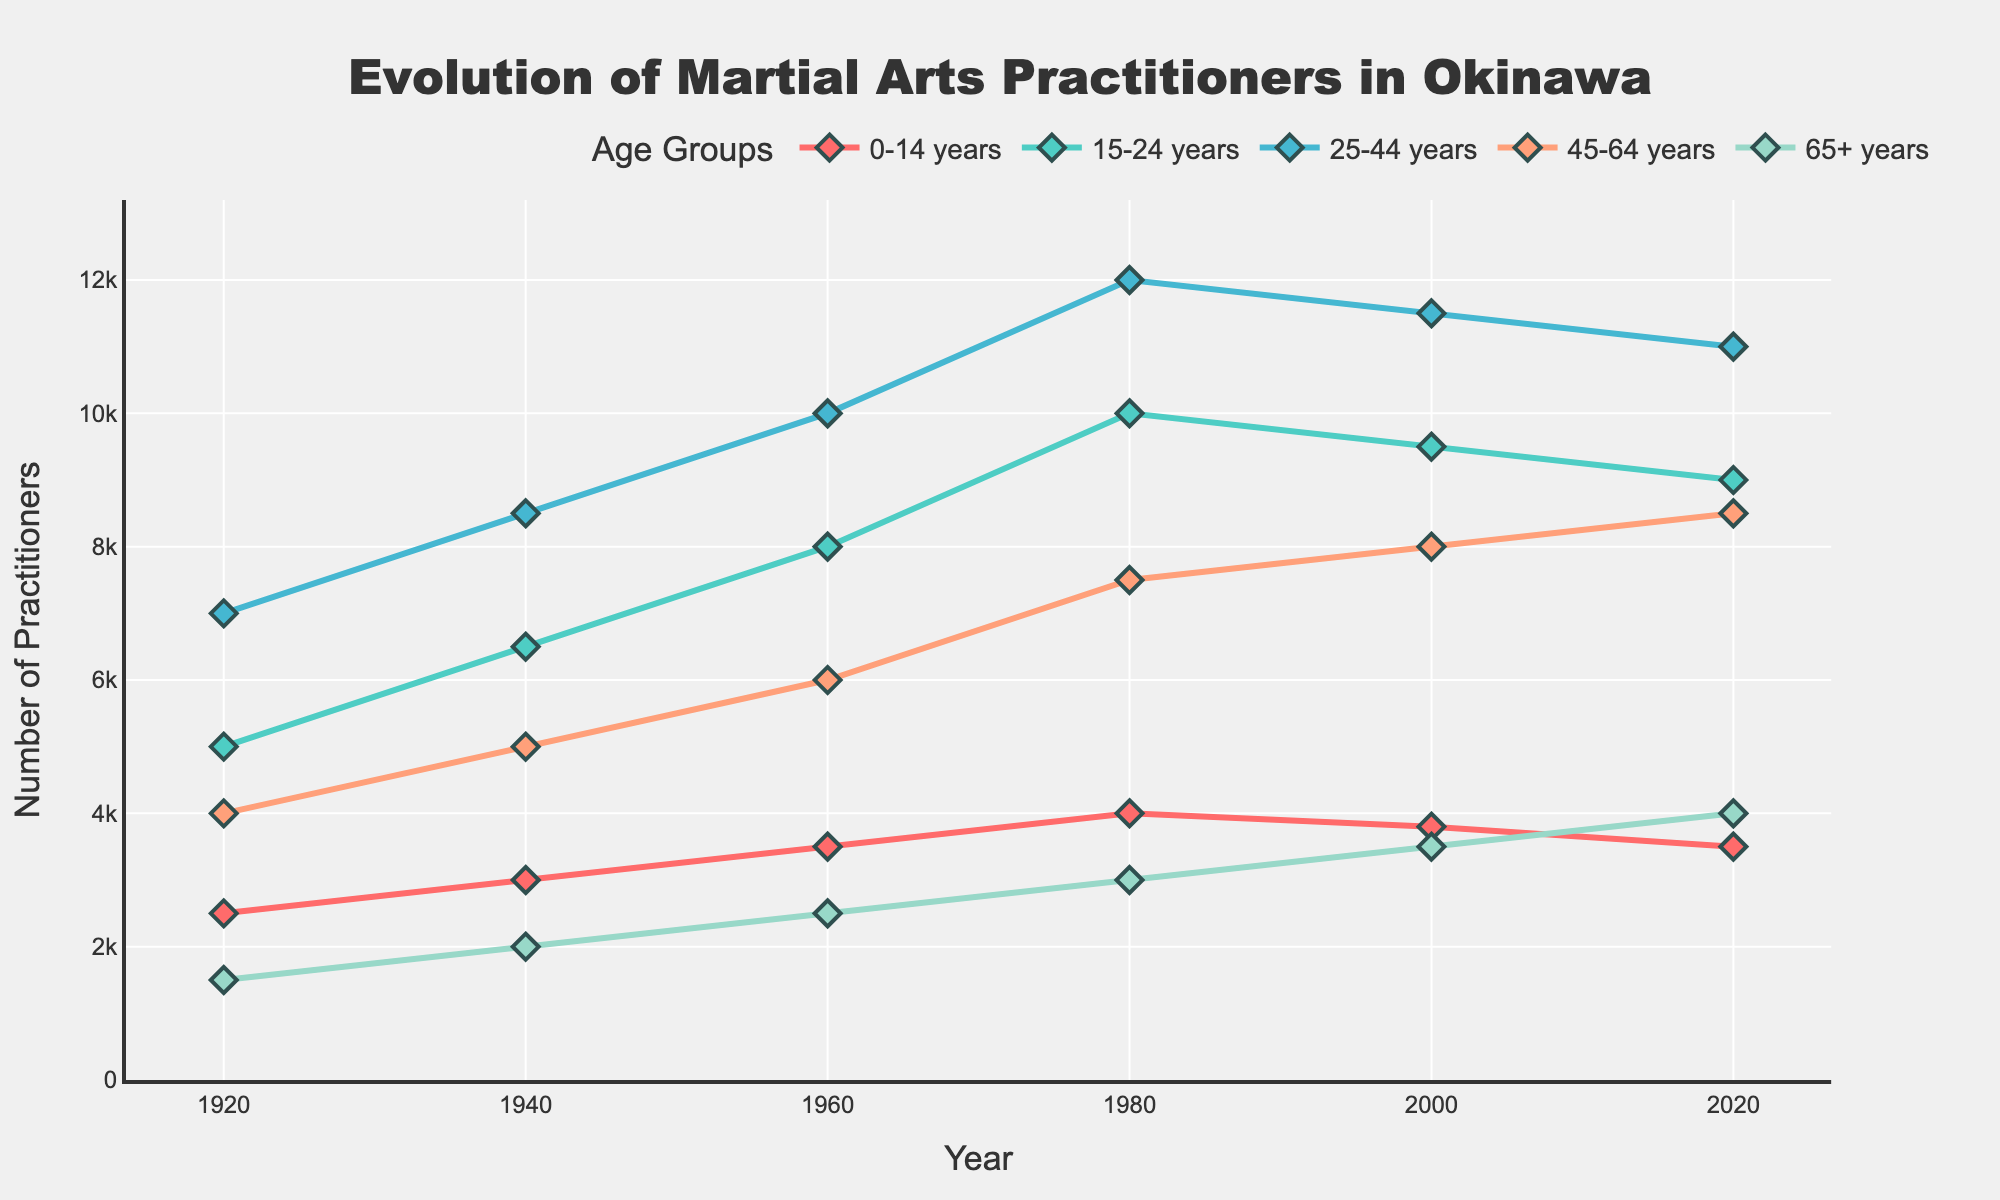What's the trend in the number of martial arts practitioners aged 0-14 years from 1920 to 2020? Look at the line corresponding to the age group 0-14 years. In 1920, the number of practitioners was 2500. It increased steadily to a peak of 4000 in 1980, then gradually decreased, reaching 3500 in 2020.
Answer: A rise followed by a decline Which age group had the highest number of practitioners in 1980? Analyze the data points for the year 1980 and compare them across all age groups. The age group with 12000 practitioners, which is the highest, is 25-44 years.
Answer: 25-44 years What is the average number of practitioners in the age group 65+ years across all years? Calculate the sum of the number of practitioners for the age group 65+ years (1500 + 2000 + 2500 + 3000 + 3500 + 4000 = 16500). Then, divide this sum by the number of data points (6 years). 16500 / 6 = 2750
Answer: 2750 Between which consecutive decades did the number of practitioners aged 15-24 years increase the most? Look at the values for the age group 15-24 years and calculate the increase between each decade: 
1920 to 1940: 6500 - 5000 = 1500
1940 to 1960: 8000 - 6500 = 1500
1960 to 1980: 10000 - 8000 = 2000
1980 to 2000: 9500 - 10000 = -500
2000 to 2020: 9000 - 9500 = -500
The biggest increase is from 1960 to 1980.
Answer: 1960 to 1980 By how much did the number of practitioners aged 45-64 years change from 1940 to 2020? Subtract the number of practitioners aged 45-64 years in 1940 from that in 2020: 8500 - 5000 = 3500
Answer: 3500 What's the difference in the number of practitioners aged 25-44 years between 2000 and 2020? Subtract the number of practitioners aged 25-44 years in 2020 from that in 2000: 11500 - 11000 = 500
Answer: 500 Which age group saw the least variation in the number of practitioners over the years? Calculate the range (maximum - minimum) for each age group:
0-14 years: 4000 - 2500 = 1500
15-24 years: 10000 - 5000 = 5000
25-44 years: 12000 - 7000 = 5000
45-64 years: 8500 - 4000 = 4500
65+ years: 4000 - 1500 = 2500
The age group 0-14 years has the smallest range of 1500.
Answer: 0-14 years In which year did the age group 0-14 years have the highest number of practitioners? Identify the highest data point for the age group 0-14 years and find its corresponding year. The peak of 4000 practitioners appears in 1980.
Answer: 1980 